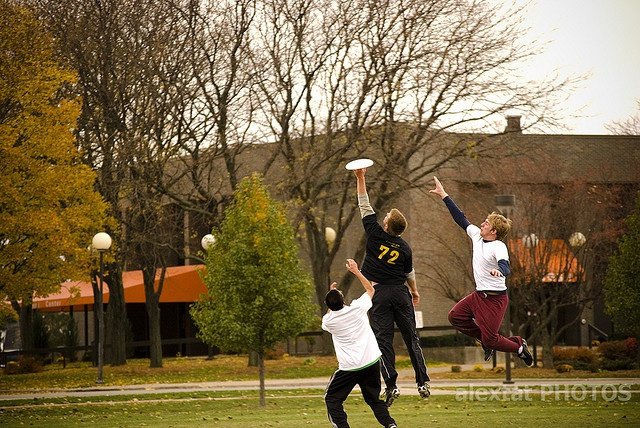Describe the objects in this image and their specific colors. I can see people in maroon, black, olive, and gray tones, people in maroon, black, white, and brown tones, people in maroon, black, white, olive, and tan tones, and frisbee in maroon, white, gray, tan, and olive tones in this image. 